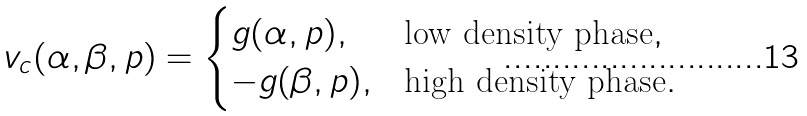<formula> <loc_0><loc_0><loc_500><loc_500>v _ { c } ( \alpha , \beta , p ) = \begin{cases} g ( \alpha , p ) , & \text {low density phase} , \\ - g ( \beta , p ) , & \text {high density phase} . \end{cases}</formula> 